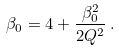Convert formula to latex. <formula><loc_0><loc_0><loc_500><loc_500>\beta _ { 0 } = 4 + \frac { \beta _ { 0 } ^ { 2 } } { 2 Q ^ { 2 } } \, .</formula> 